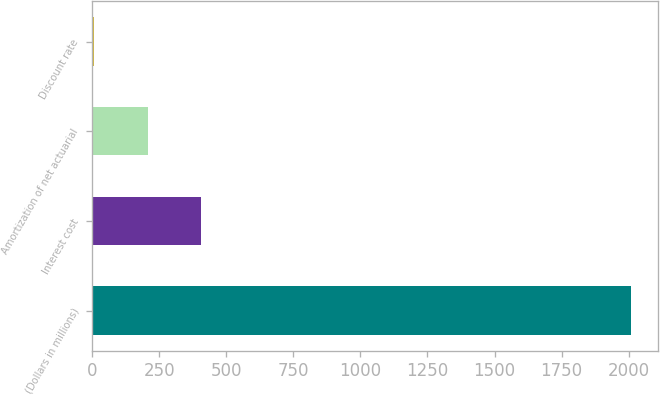Convert chart to OTSL. <chart><loc_0><loc_0><loc_500><loc_500><bar_chart><fcel>(Dollars in millions)<fcel>Interest cost<fcel>Amortization of net actuarial<fcel>Discount rate<nl><fcel>2008<fcel>406.4<fcel>206.2<fcel>6<nl></chart> 